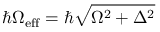Convert formula to latex. <formula><loc_0><loc_0><loc_500><loc_500>\hbar { \Omega } _ { e f f } = \hbar { \sqrt } { \Omega ^ { 2 } + \Delta ^ { 2 } }</formula> 